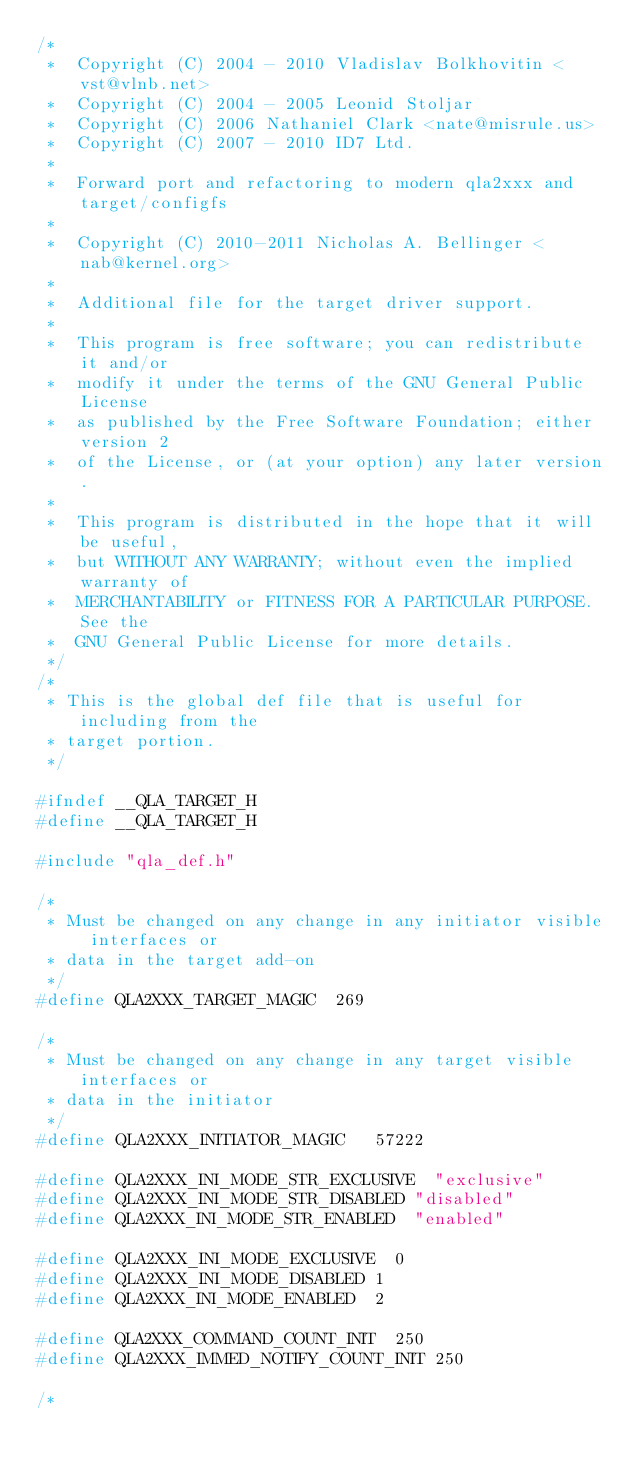<code> <loc_0><loc_0><loc_500><loc_500><_C_>/*
 *  Copyright (C) 2004 - 2010 Vladislav Bolkhovitin <vst@vlnb.net>
 *  Copyright (C) 2004 - 2005 Leonid Stoljar
 *  Copyright (C) 2006 Nathaniel Clark <nate@misrule.us>
 *  Copyright (C) 2007 - 2010 ID7 Ltd.
 *
 *  Forward port and refactoring to modern qla2xxx and target/configfs
 *
 *  Copyright (C) 2010-2011 Nicholas A. Bellinger <nab@kernel.org>
 *
 *  Additional file for the target driver support.
 *
 *  This program is free software; you can redistribute it and/or
 *  modify it under the terms of the GNU General Public License
 *  as published by the Free Software Foundation; either version 2
 *  of the License, or (at your option) any later version.
 *
 *  This program is distributed in the hope that it will be useful,
 *  but WITHOUT ANY WARRANTY; without even the implied warranty of
 *  MERCHANTABILITY or FITNESS FOR A PARTICULAR PURPOSE. See the
 *  GNU General Public License for more details.
 */
/*
 * This is the global def file that is useful for including from the
 * target portion.
 */

#ifndef __QLA_TARGET_H
#define __QLA_TARGET_H

#include "qla_def.h"

/*
 * Must be changed on any change in any initiator visible interfaces or
 * data in the target add-on
 */
#define QLA2XXX_TARGET_MAGIC	269

/*
 * Must be changed on any change in any target visible interfaces or
 * data in the initiator
 */
#define QLA2XXX_INITIATOR_MAGIC   57222

#define QLA2XXX_INI_MODE_STR_EXCLUSIVE	"exclusive"
#define QLA2XXX_INI_MODE_STR_DISABLED	"disabled"
#define QLA2XXX_INI_MODE_STR_ENABLED	"enabled"

#define QLA2XXX_INI_MODE_EXCLUSIVE	0
#define QLA2XXX_INI_MODE_DISABLED	1
#define QLA2XXX_INI_MODE_ENABLED	2

#define QLA2XXX_COMMAND_COUNT_INIT	250
#define QLA2XXX_IMMED_NOTIFY_COUNT_INIT 250

/*</code> 